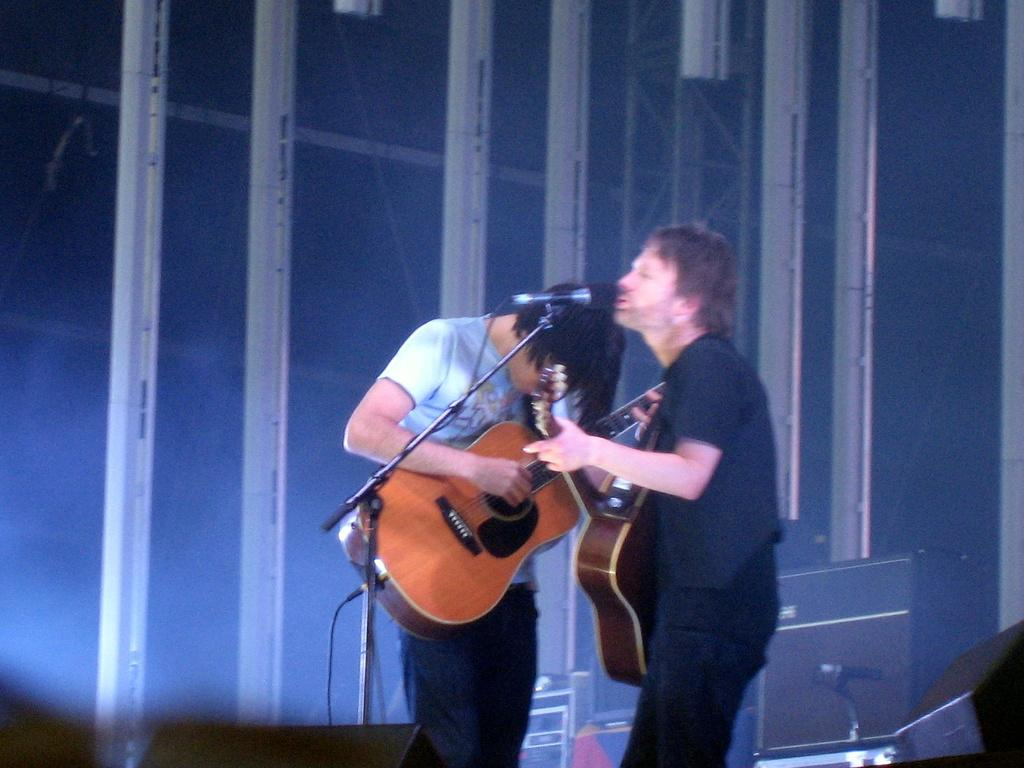How many people are in the image? There are two persons in the image. What are the persons doing in the image? Both persons are standing and holding guitars. Can you describe the object between the two persons? There is a microphone between the two persons. What type of goose can be seen playing with a house and glass in the image? There is no goose, house, or glass present in the image. 